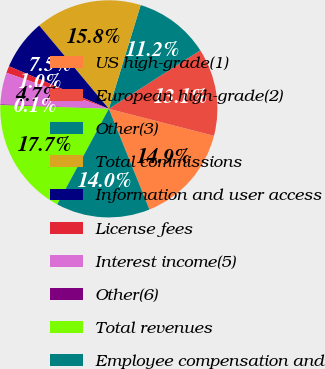<chart> <loc_0><loc_0><loc_500><loc_500><pie_chart><fcel>US high-grade(1)<fcel>European high-grade(2)<fcel>Other(3)<fcel>Total commissions<fcel>Information and user access<fcel>License fees<fcel>Interest income(5)<fcel>Other(6)<fcel>Total revenues<fcel>Employee compensation and<nl><fcel>14.9%<fcel>13.05%<fcel>11.2%<fcel>15.82%<fcel>7.5%<fcel>1.03%<fcel>4.73%<fcel>0.11%<fcel>17.67%<fcel>13.98%<nl></chart> 